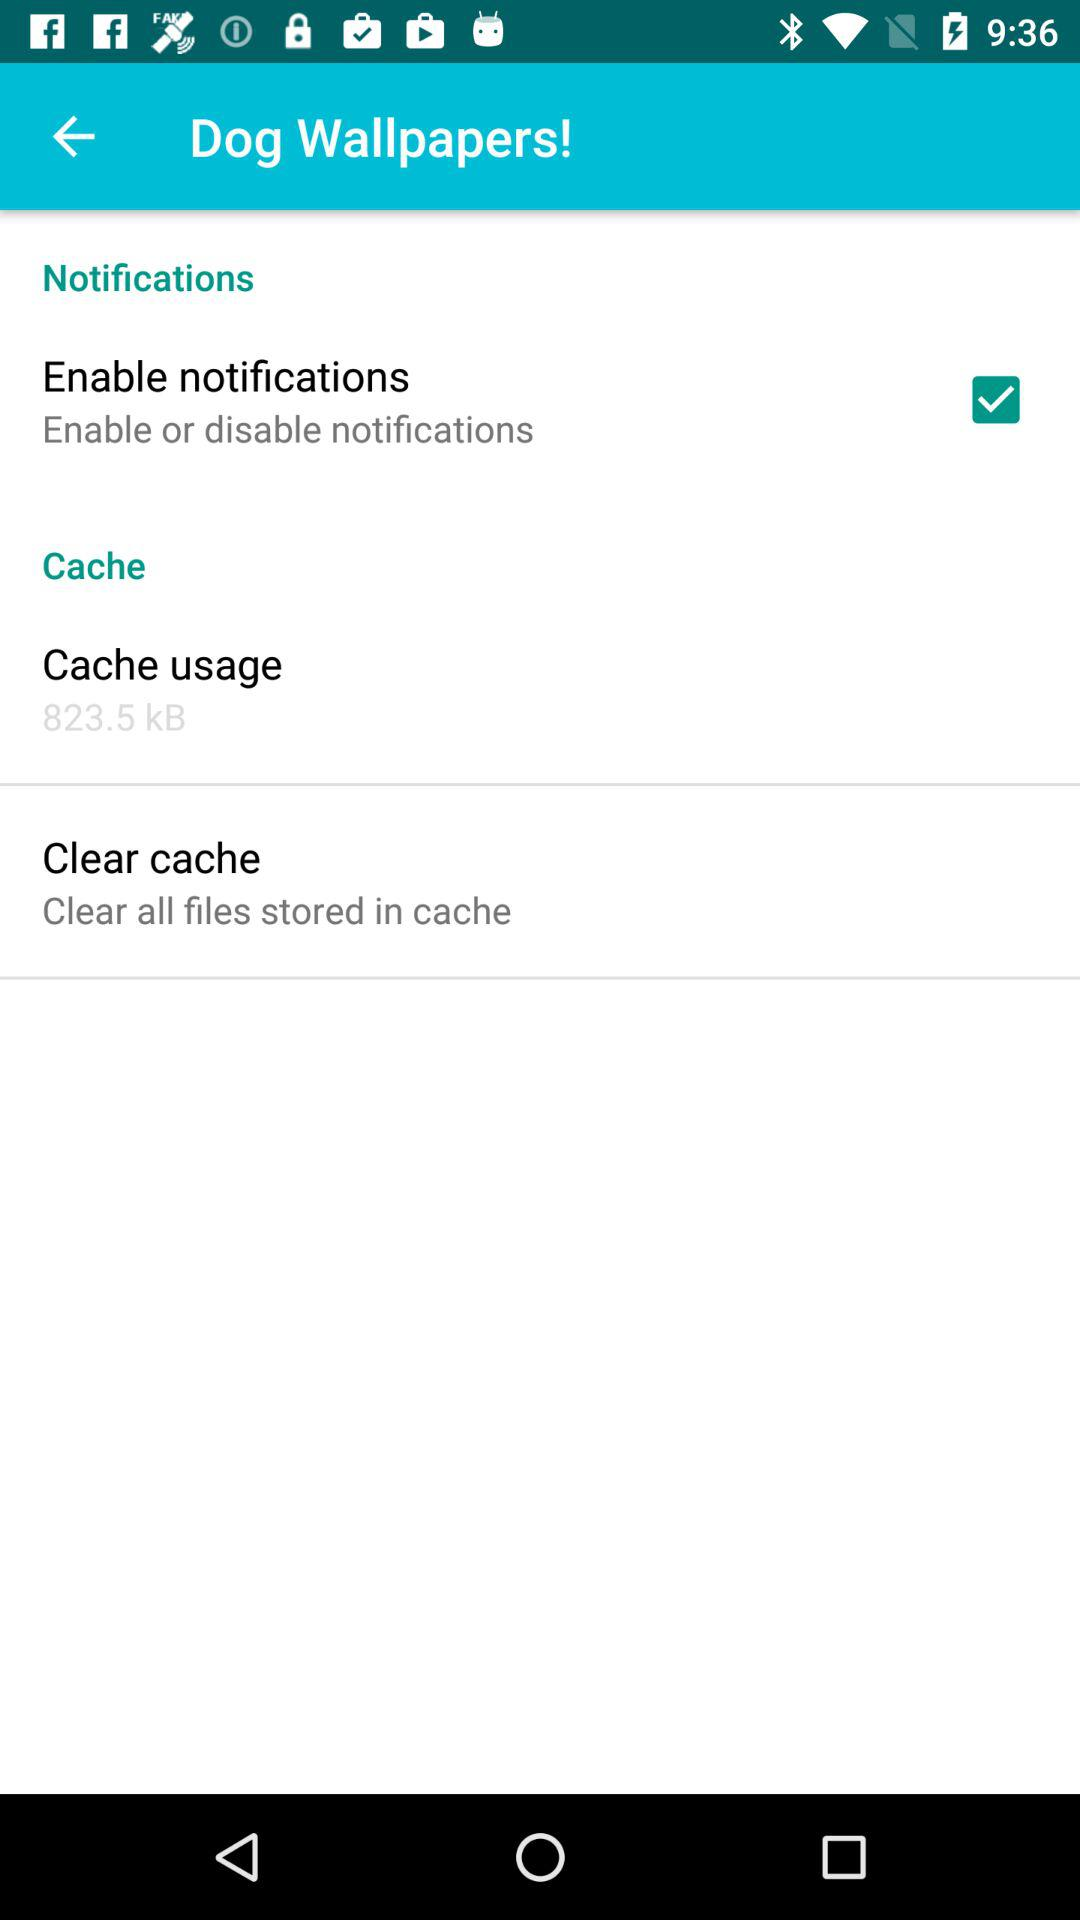What is the status of "Enable notifications"? The status of "Enable notifications" is "on". 